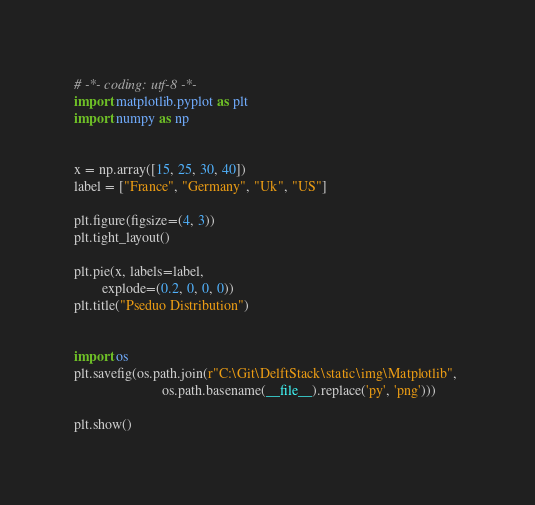Convert code to text. <code><loc_0><loc_0><loc_500><loc_500><_Python_>
# -*- coding: utf-8 -*-
import matplotlib.pyplot as plt
import numpy as np


x = np.array([15, 25, 30, 40])
label = ["France", "Germany", "Uk", "US"]

plt.figure(figsize=(4, 3))
plt.tight_layout()

plt.pie(x, labels=label,
        explode=(0.2, 0, 0, 0))
plt.title("Pseduo Distribution")


import os
plt.savefig(os.path.join(r"C:\Git\DelftStack\static\img\Matplotlib", 
                         os.path.basename(__file__).replace('py', 'png')))

plt.show()</code> 